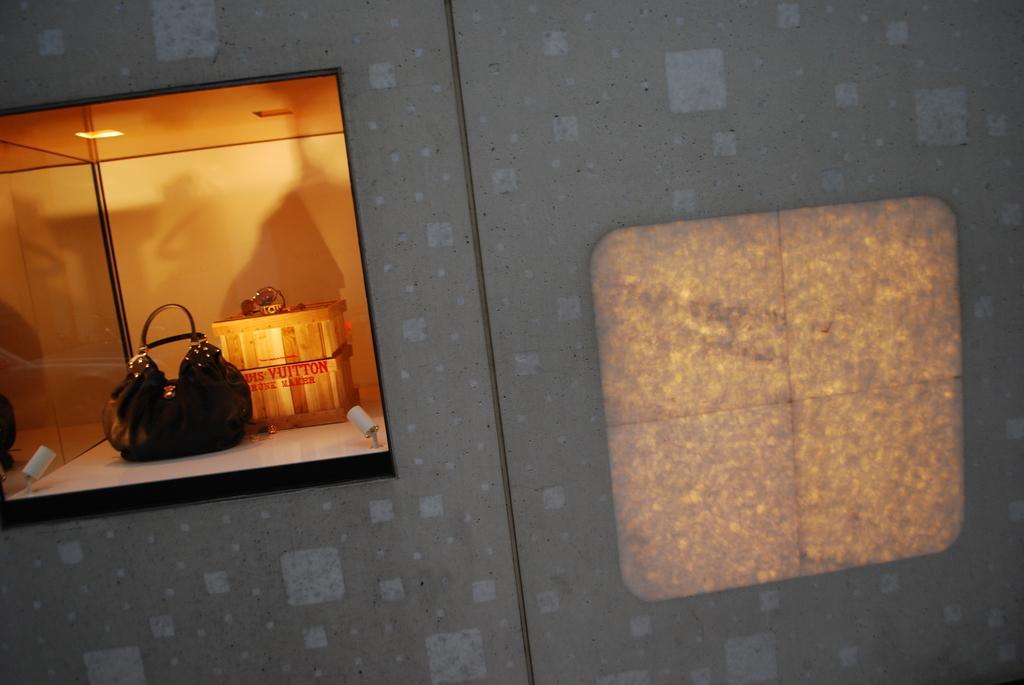Could you give a brief overview of what you see in this image? In this image I can see a bag and a wooden-box inside the window. 